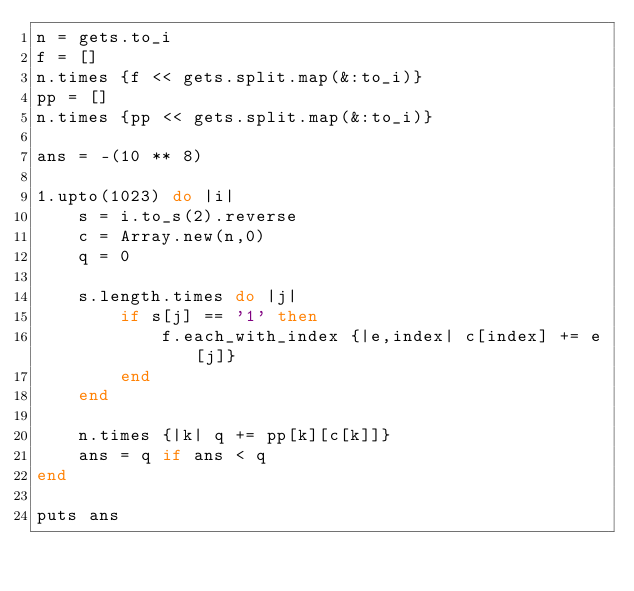<code> <loc_0><loc_0><loc_500><loc_500><_Ruby_>n = gets.to_i
f = []
n.times {f << gets.split.map(&:to_i)}
pp = []
n.times {pp << gets.split.map(&:to_i)}

ans = -(10 ** 8)

1.upto(1023) do |i|
    s = i.to_s(2).reverse
    c = Array.new(n,0)
    q = 0

    s.length.times do |j|
        if s[j] == '1' then
            f.each_with_index {|e,index| c[index] += e[j]}
        end
    end

    n.times {|k| q += pp[k][c[k]]}
    ans = q if ans < q
end

puts ans</code> 